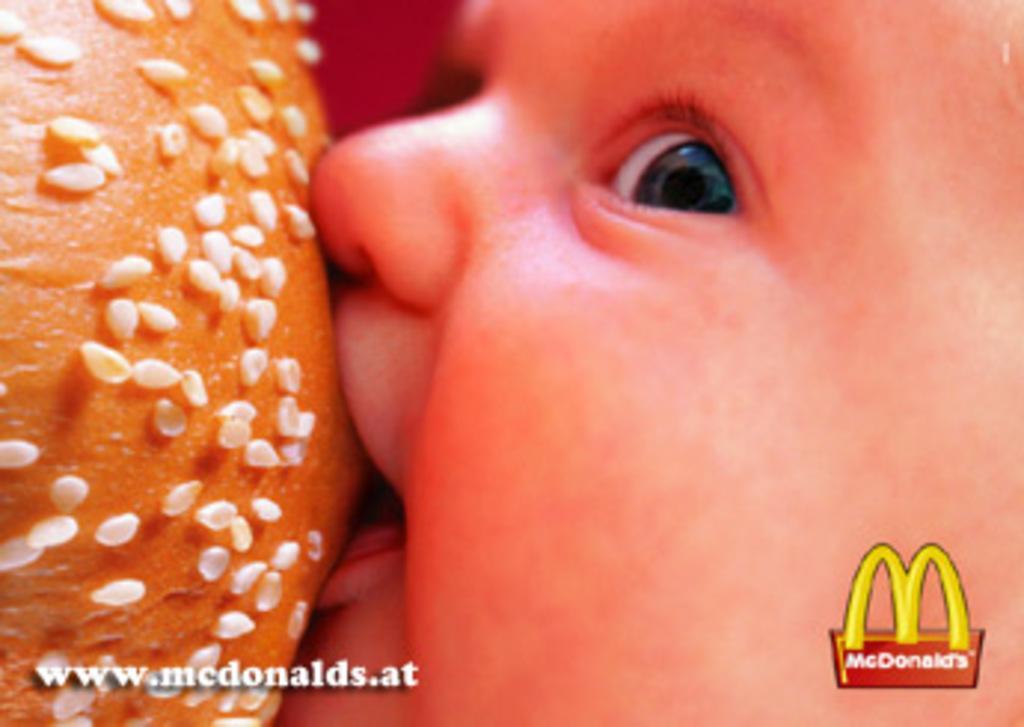Can you describe this image briefly? In this picture I can see a kid eating a bun and there are watermarks on the image. 